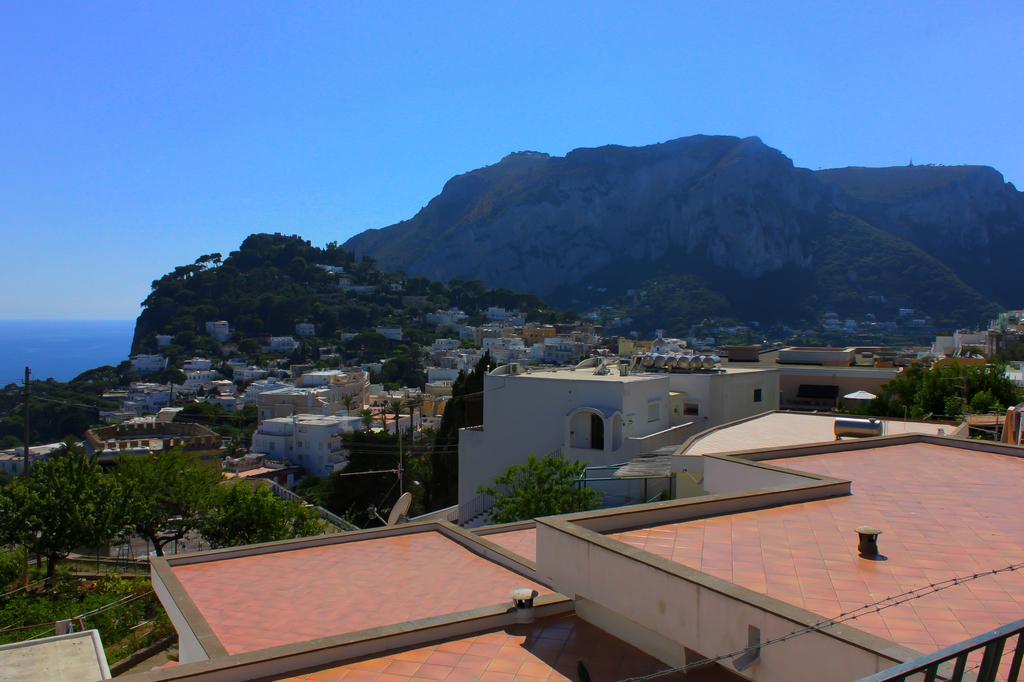Please provide a concise description of this image. Here we can see houses, poles, and trees. There is a mountain. In the background there is sky. 